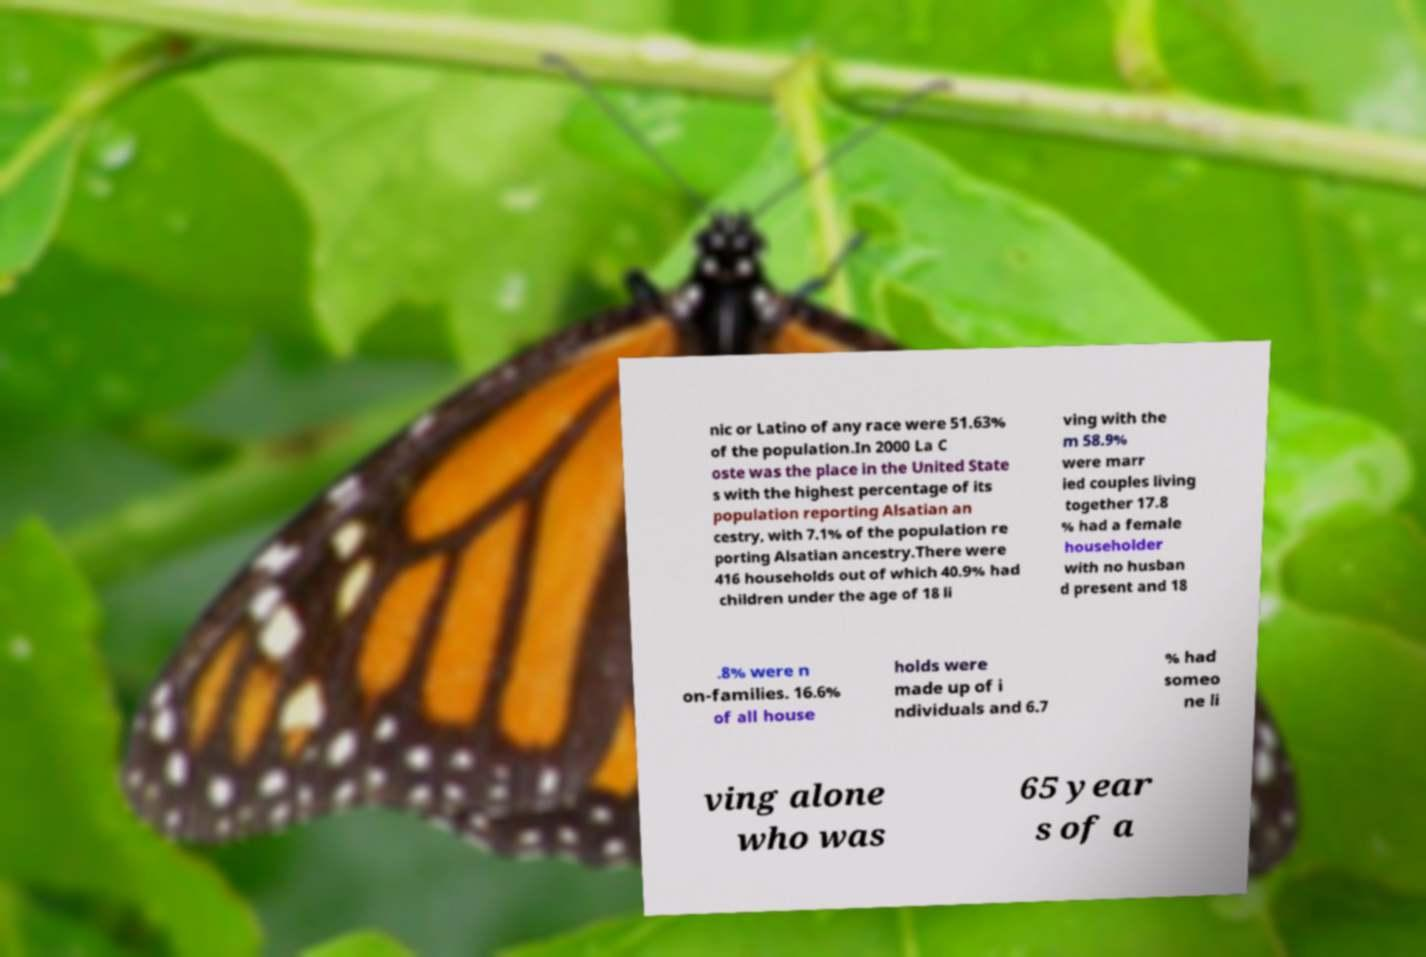Could you extract and type out the text from this image? nic or Latino of any race were 51.63% of the population.In 2000 La C oste was the place in the United State s with the highest percentage of its population reporting Alsatian an cestry, with 7.1% of the population re porting Alsatian ancestry.There were 416 households out of which 40.9% had children under the age of 18 li ving with the m 58.9% were marr ied couples living together 17.8 % had a female householder with no husban d present and 18 .8% were n on-families. 16.6% of all house holds were made up of i ndividuals and 6.7 % had someo ne li ving alone who was 65 year s of a 